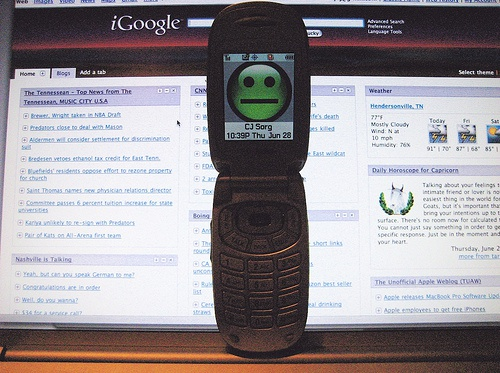Describe the objects in this image and their specific colors. I can see laptop in white, black, maroon, and darkgray tones and cell phone in black, gray, and darkgray tones in this image. 